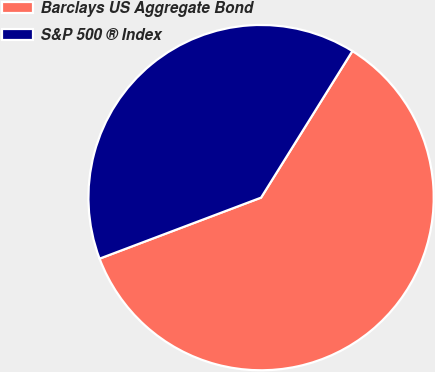Convert chart. <chart><loc_0><loc_0><loc_500><loc_500><pie_chart><fcel>Barclays US Aggregate Bond<fcel>S&P 500 ® Index<nl><fcel>60.38%<fcel>39.62%<nl></chart> 